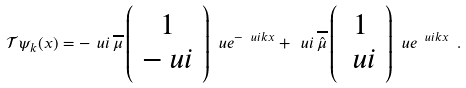Convert formula to latex. <formula><loc_0><loc_0><loc_500><loc_500>\mathcal { T } \psi _ { k } ( x ) = - \ u i \, \overline { \mu } \left ( \begin{array} { c } 1 \\ - \ u i \\ \end{array} \right ) \ u e ^ { - \ u i k x } + \ u i \, \overline { \hat { \mu } } \left ( \begin{array} { c } 1 \\ \ u i \\ \end{array} \right ) \ u e ^ { \ u i k x } \ .</formula> 